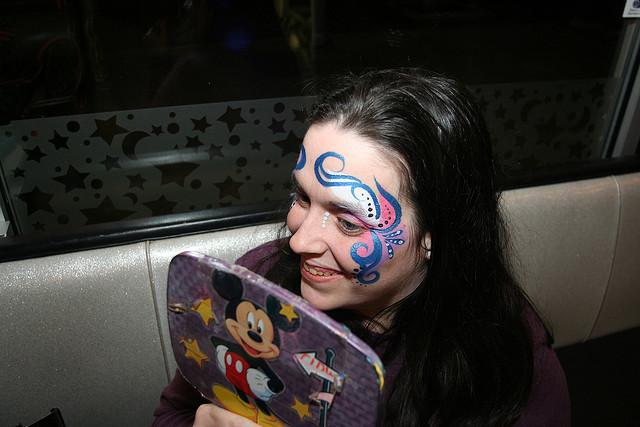Is her face painted?
Answer briefly. Yes. What time of day does it appear to be in this photo?
Keep it brief. Night. What Disney character is in the picture?
Quick response, please. Mickey mouse. 